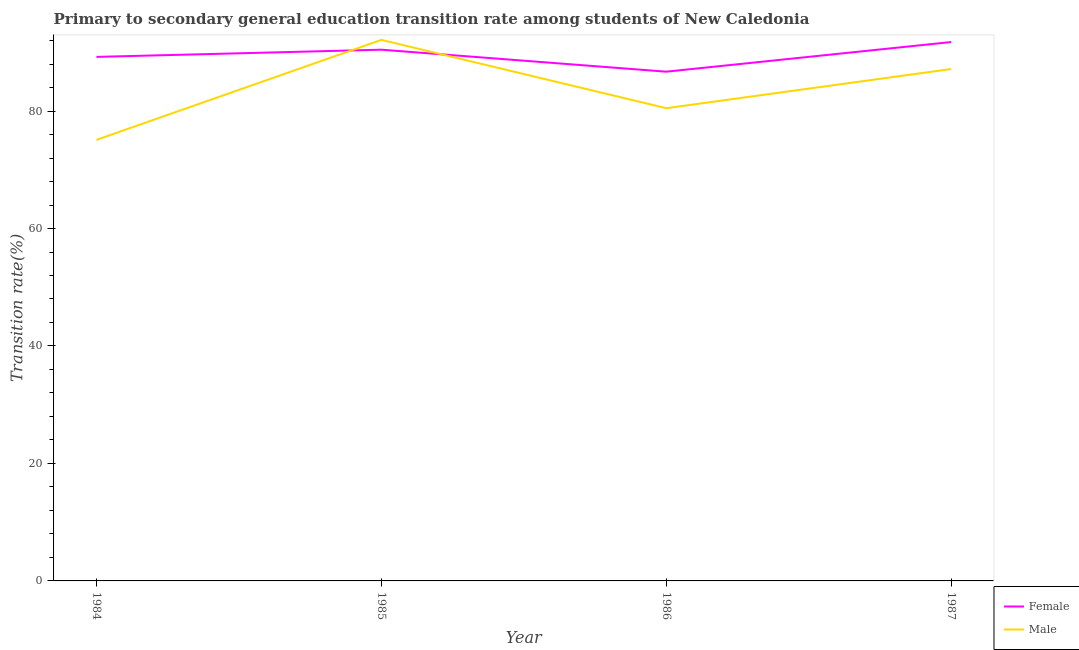How many different coloured lines are there?
Make the answer very short. 2. What is the transition rate among male students in 1985?
Provide a succinct answer. 92.12. Across all years, what is the maximum transition rate among female students?
Your answer should be very brief. 91.75. Across all years, what is the minimum transition rate among male students?
Provide a short and direct response. 75.09. In which year was the transition rate among male students minimum?
Keep it short and to the point. 1984. What is the total transition rate among female students in the graph?
Give a very brief answer. 358.12. What is the difference between the transition rate among female students in 1985 and that in 1987?
Give a very brief answer. -1.3. What is the difference between the transition rate among female students in 1986 and the transition rate among male students in 1984?
Provide a short and direct response. 11.61. What is the average transition rate among male students per year?
Offer a terse response. 83.71. In the year 1986, what is the difference between the transition rate among female students and transition rate among male students?
Provide a short and direct response. 6.22. In how many years, is the transition rate among female students greater than 20 %?
Make the answer very short. 4. What is the ratio of the transition rate among female students in 1984 to that in 1986?
Your response must be concise. 1.03. Is the difference between the transition rate among female students in 1984 and 1986 greater than the difference between the transition rate among male students in 1984 and 1986?
Offer a terse response. Yes. What is the difference between the highest and the second highest transition rate among male students?
Give a very brief answer. 4.96. What is the difference between the highest and the lowest transition rate among male students?
Give a very brief answer. 17.03. Does the transition rate among male students monotonically increase over the years?
Give a very brief answer. No. How many years are there in the graph?
Provide a succinct answer. 4. What is the difference between two consecutive major ticks on the Y-axis?
Your response must be concise. 20. Does the graph contain any zero values?
Make the answer very short. No. Does the graph contain grids?
Make the answer very short. No. Where does the legend appear in the graph?
Your answer should be compact. Bottom right. How many legend labels are there?
Offer a terse response. 2. What is the title of the graph?
Offer a very short reply. Primary to secondary general education transition rate among students of New Caledonia. What is the label or title of the Y-axis?
Provide a succinct answer. Transition rate(%). What is the Transition rate(%) in Female in 1984?
Your answer should be compact. 89.22. What is the Transition rate(%) of Male in 1984?
Your response must be concise. 75.09. What is the Transition rate(%) in Female in 1985?
Your response must be concise. 90.45. What is the Transition rate(%) of Male in 1985?
Ensure brevity in your answer.  92.12. What is the Transition rate(%) of Female in 1986?
Provide a succinct answer. 86.7. What is the Transition rate(%) in Male in 1986?
Ensure brevity in your answer.  80.48. What is the Transition rate(%) in Female in 1987?
Offer a very short reply. 91.75. What is the Transition rate(%) of Male in 1987?
Your response must be concise. 87.15. Across all years, what is the maximum Transition rate(%) in Female?
Make the answer very short. 91.75. Across all years, what is the maximum Transition rate(%) in Male?
Provide a short and direct response. 92.12. Across all years, what is the minimum Transition rate(%) of Female?
Your response must be concise. 86.7. Across all years, what is the minimum Transition rate(%) of Male?
Your response must be concise. 75.09. What is the total Transition rate(%) of Female in the graph?
Give a very brief answer. 358.12. What is the total Transition rate(%) of Male in the graph?
Your answer should be compact. 334.85. What is the difference between the Transition rate(%) of Female in 1984 and that in 1985?
Your response must be concise. -1.23. What is the difference between the Transition rate(%) in Male in 1984 and that in 1985?
Make the answer very short. -17.03. What is the difference between the Transition rate(%) of Female in 1984 and that in 1986?
Provide a succinct answer. 2.52. What is the difference between the Transition rate(%) in Male in 1984 and that in 1986?
Your response must be concise. -5.39. What is the difference between the Transition rate(%) of Female in 1984 and that in 1987?
Give a very brief answer. -2.53. What is the difference between the Transition rate(%) of Male in 1984 and that in 1987?
Give a very brief answer. -12.06. What is the difference between the Transition rate(%) of Female in 1985 and that in 1986?
Make the answer very short. 3.75. What is the difference between the Transition rate(%) of Male in 1985 and that in 1986?
Offer a very short reply. 11.63. What is the difference between the Transition rate(%) of Female in 1985 and that in 1987?
Provide a succinct answer. -1.3. What is the difference between the Transition rate(%) of Male in 1985 and that in 1987?
Your answer should be compact. 4.96. What is the difference between the Transition rate(%) in Female in 1986 and that in 1987?
Give a very brief answer. -5.05. What is the difference between the Transition rate(%) in Male in 1986 and that in 1987?
Provide a succinct answer. -6.67. What is the difference between the Transition rate(%) in Female in 1984 and the Transition rate(%) in Male in 1985?
Provide a succinct answer. -2.9. What is the difference between the Transition rate(%) of Female in 1984 and the Transition rate(%) of Male in 1986?
Your answer should be very brief. 8.73. What is the difference between the Transition rate(%) in Female in 1984 and the Transition rate(%) in Male in 1987?
Your answer should be compact. 2.07. What is the difference between the Transition rate(%) of Female in 1985 and the Transition rate(%) of Male in 1986?
Offer a terse response. 9.96. What is the difference between the Transition rate(%) of Female in 1985 and the Transition rate(%) of Male in 1987?
Your answer should be very brief. 3.29. What is the difference between the Transition rate(%) of Female in 1986 and the Transition rate(%) of Male in 1987?
Keep it short and to the point. -0.45. What is the average Transition rate(%) of Female per year?
Your answer should be compact. 89.53. What is the average Transition rate(%) of Male per year?
Offer a terse response. 83.71. In the year 1984, what is the difference between the Transition rate(%) in Female and Transition rate(%) in Male?
Give a very brief answer. 14.13. In the year 1985, what is the difference between the Transition rate(%) of Female and Transition rate(%) of Male?
Your answer should be compact. -1.67. In the year 1986, what is the difference between the Transition rate(%) of Female and Transition rate(%) of Male?
Your answer should be very brief. 6.22. In the year 1987, what is the difference between the Transition rate(%) in Female and Transition rate(%) in Male?
Offer a terse response. 4.6. What is the ratio of the Transition rate(%) in Female in 1984 to that in 1985?
Give a very brief answer. 0.99. What is the ratio of the Transition rate(%) of Male in 1984 to that in 1985?
Provide a succinct answer. 0.82. What is the ratio of the Transition rate(%) in Female in 1984 to that in 1986?
Your response must be concise. 1.03. What is the ratio of the Transition rate(%) of Male in 1984 to that in 1986?
Provide a succinct answer. 0.93. What is the ratio of the Transition rate(%) in Female in 1984 to that in 1987?
Your response must be concise. 0.97. What is the ratio of the Transition rate(%) of Male in 1984 to that in 1987?
Give a very brief answer. 0.86. What is the ratio of the Transition rate(%) in Female in 1985 to that in 1986?
Offer a terse response. 1.04. What is the ratio of the Transition rate(%) in Male in 1985 to that in 1986?
Give a very brief answer. 1.14. What is the ratio of the Transition rate(%) in Female in 1985 to that in 1987?
Provide a succinct answer. 0.99. What is the ratio of the Transition rate(%) in Male in 1985 to that in 1987?
Make the answer very short. 1.06. What is the ratio of the Transition rate(%) in Female in 1986 to that in 1987?
Provide a short and direct response. 0.94. What is the ratio of the Transition rate(%) in Male in 1986 to that in 1987?
Provide a succinct answer. 0.92. What is the difference between the highest and the second highest Transition rate(%) in Female?
Give a very brief answer. 1.3. What is the difference between the highest and the second highest Transition rate(%) of Male?
Offer a very short reply. 4.96. What is the difference between the highest and the lowest Transition rate(%) in Female?
Your answer should be very brief. 5.05. What is the difference between the highest and the lowest Transition rate(%) in Male?
Provide a succinct answer. 17.03. 